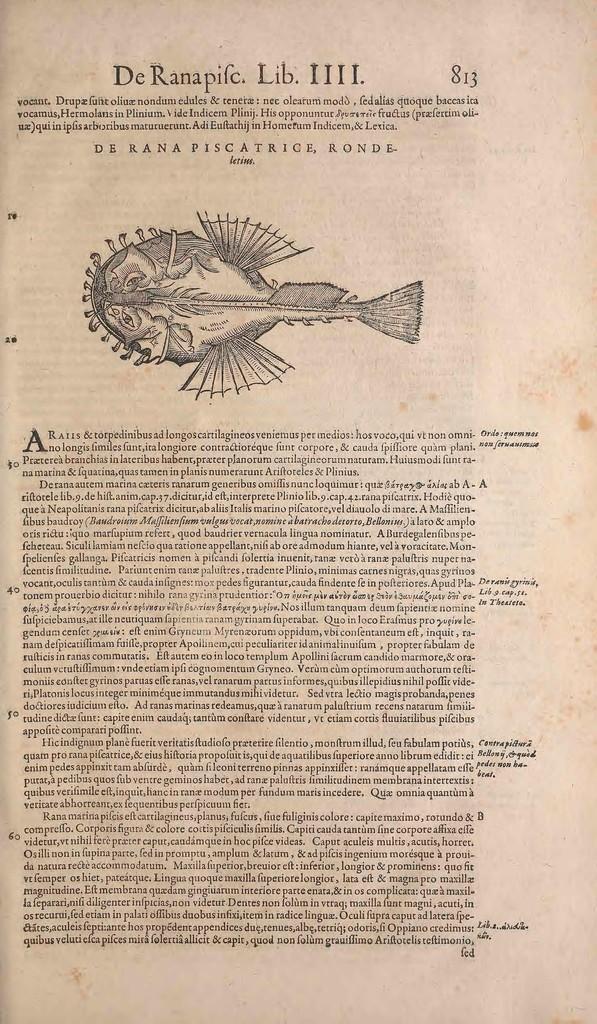Please provide a concise description of this image. This is a picture of a paper, where there are numbers, paragraphs, page number, and a image of an animal on the paper. 